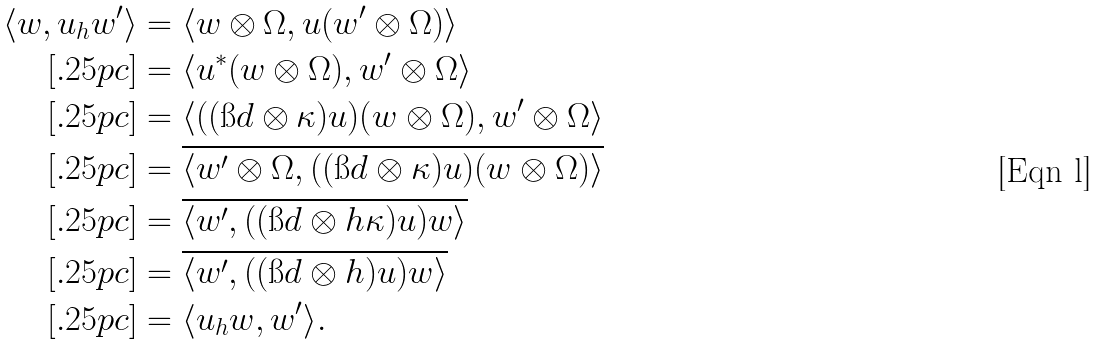<formula> <loc_0><loc_0><loc_500><loc_500>\langle w , u _ { h } w ^ { \prime } \rangle & = \langle w \otimes \Omega , u ( w ^ { \prime } \otimes \Omega ) \rangle \\ [ . 2 5 p c ] & = \langle u ^ { * } ( w \otimes \Omega ) , w ^ { \prime } \otimes \Omega \rangle \\ [ . 2 5 p c ] & = \langle ( ( \i d \otimes \kappa ) u ) ( w \otimes \Omega ) , w ^ { \prime } \otimes \Omega \rangle \\ [ . 2 5 p c ] & = \overline { \langle w ^ { \prime } \otimes \Omega , ( ( \i d \otimes \kappa ) u ) ( w \otimes \Omega ) \rangle } \\ [ . 2 5 p c ] & = \overline { \langle w ^ { \prime } , ( ( \i d \otimes h \kappa ) u ) w \rangle } \\ [ . 2 5 p c ] & = \overline { \langle w ^ { \prime } , ( ( \i d \otimes h ) u ) w \rangle } \\ [ . 2 5 p c ] & = \langle u _ { h } w , w ^ { \prime } \rangle .</formula> 